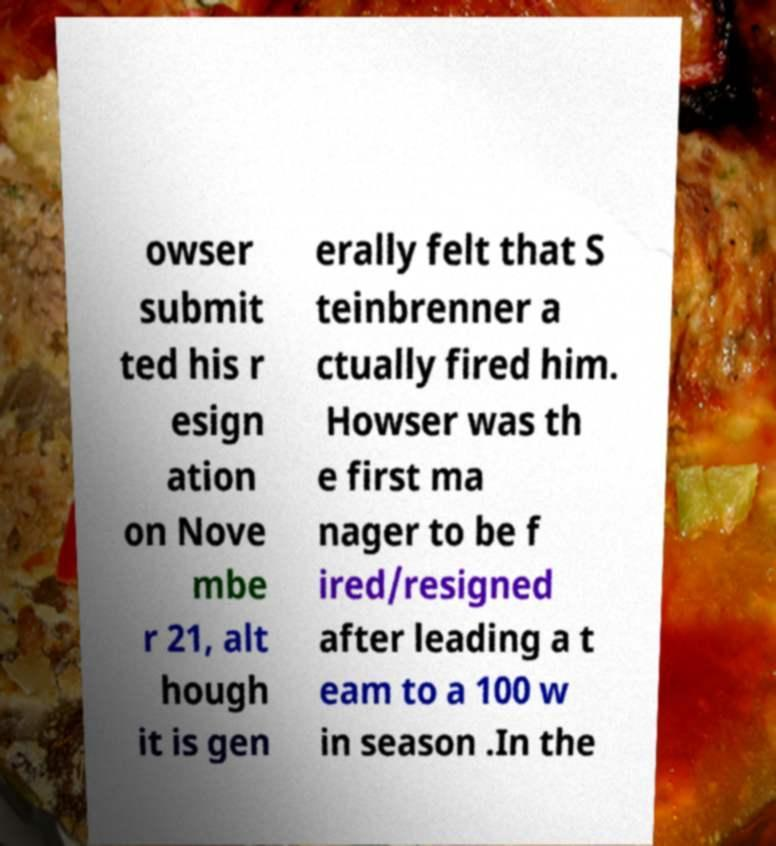Please identify and transcribe the text found in this image. owser submit ted his r esign ation on Nove mbe r 21, alt hough it is gen erally felt that S teinbrenner a ctually fired him. Howser was th e first ma nager to be f ired/resigned after leading a t eam to a 100 w in season .In the 